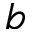Convert formula to latex. <formula><loc_0><loc_0><loc_500><loc_500>b</formula> 